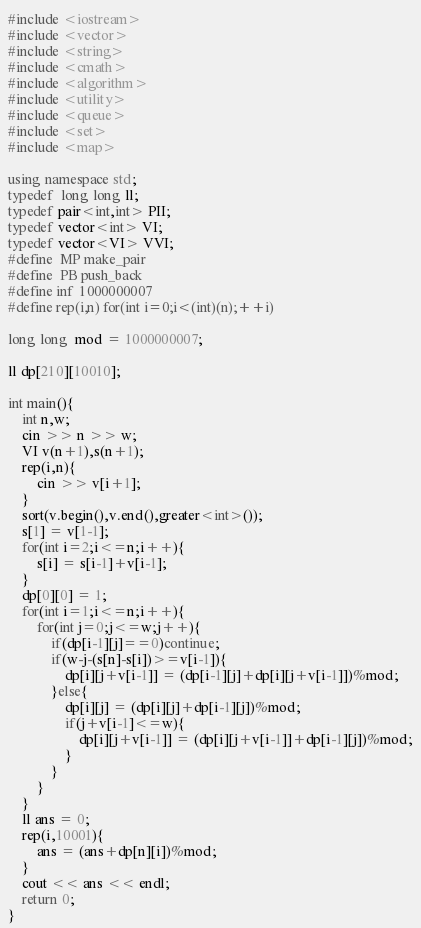<code> <loc_0><loc_0><loc_500><loc_500><_C++_>#include <iostream>
#include <vector>
#include <string>
#include <cmath>
#include <algorithm>
#include <utility>
#include <queue>
#include <set>
#include <map>

using namespace std;
typedef  long long ll;
typedef pair<int,int> PII;
typedef vector<int> VI;
typedef vector<VI> VVI;
#define  MP make_pair
#define  PB push_back
#define inf  1000000007
#define rep(i,n) for(int i=0;i<(int)(n);++i)

long long  mod = 1000000007;

ll dp[210][10010];

int main(){
	int n,w;
	cin >> n >> w;
	VI v(n+1),s(n+1);	
	rep(i,n){
		cin >> v[i+1];
	}
	sort(v.begin(),v.end(),greater<int>());
	s[1] = v[1-1];
	for(int i=2;i<=n;i++){
		s[i] = s[i-1]+v[i-1];
	}
	dp[0][0] = 1;
	for(int i=1;i<=n;i++){
		for(int j=0;j<=w;j++){
			if(dp[i-1][j]==0)continue;
			if(w-j-(s[n]-s[i])>=v[i-1]){
				dp[i][j+v[i-1]] = (dp[i-1][j]+dp[i][j+v[i-1]])%mod;
			}else{
				dp[i][j] = (dp[i][j]+dp[i-1][j])%mod;
				if(j+v[i-1]<=w){
					dp[i][j+v[i-1]] = (dp[i][j+v[i-1]]+dp[i-1][j])%mod;
				}
			}
		}
	}
	ll ans = 0;
	rep(i,10001){
		ans = (ans+dp[n][i])%mod;
	}
	cout << ans << endl;
	return 0;
}</code> 